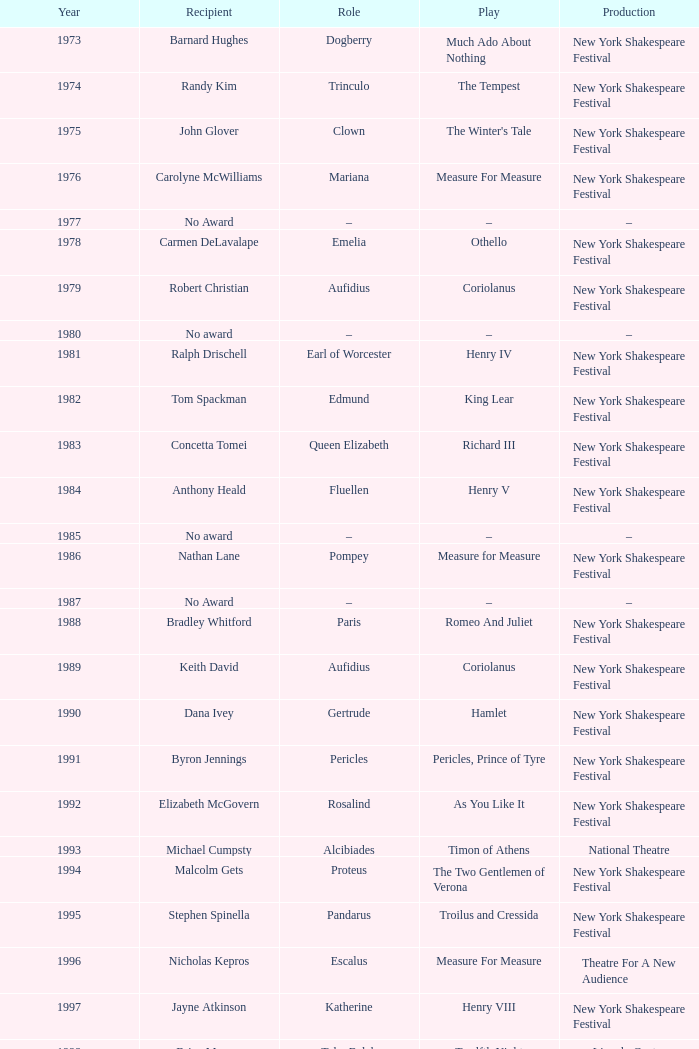State the recipient for much ado about nothing during 197 Barnard Hughes. 